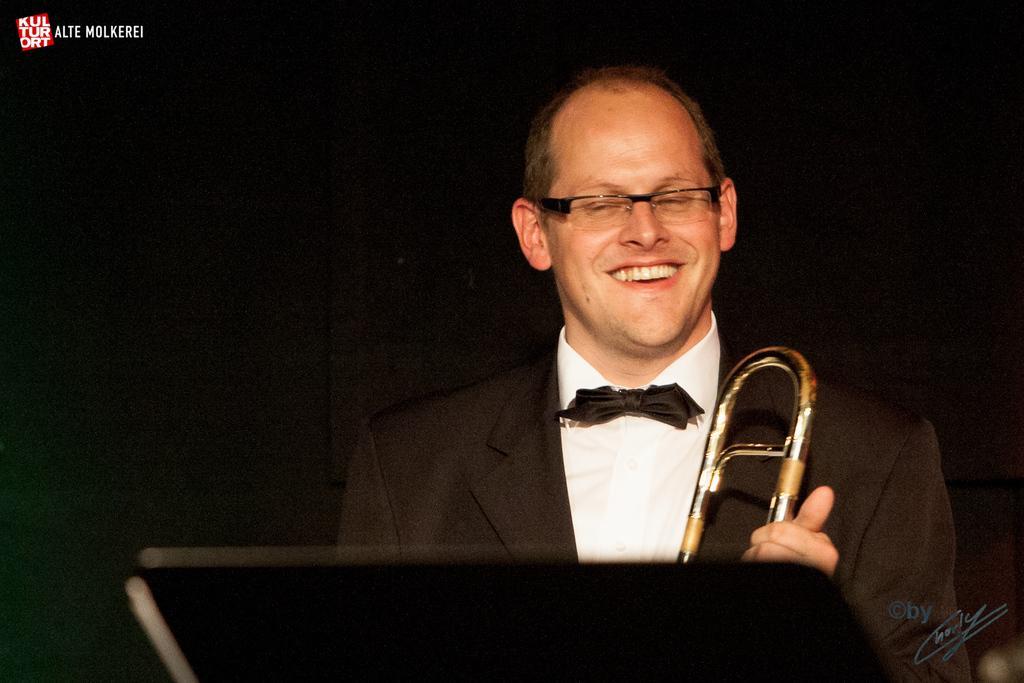Could you give a brief overview of what you see in this image? In this picture I can see a man standing and holding a musical instrument in his hand and looks like a book stand at the bottom of the picture. I can see text at the top left corner and a watermark at the bottom right corner of the picture and I can see dark background. 